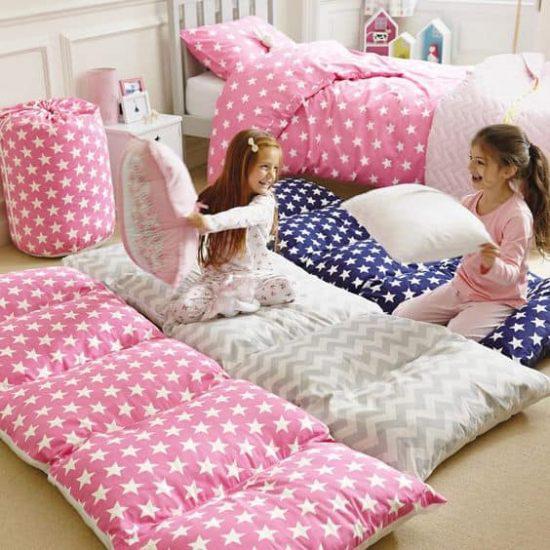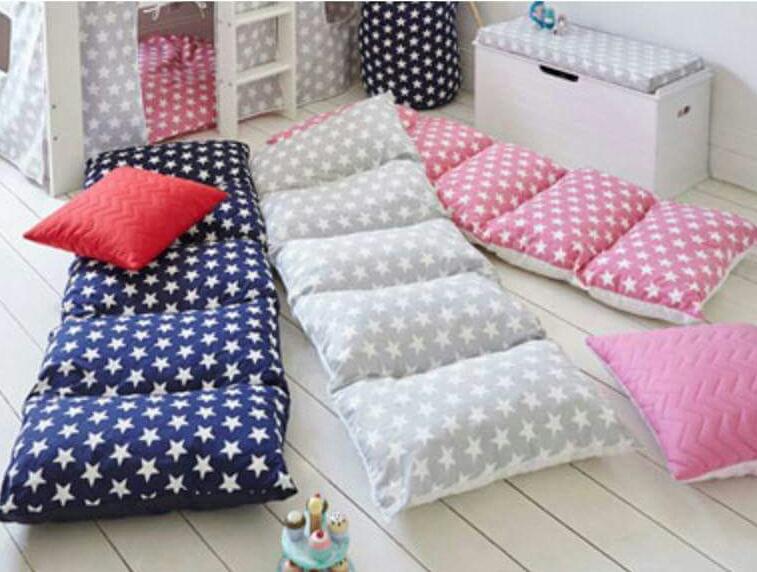The first image is the image on the left, the second image is the image on the right. Considering the images on both sides, is "In the left image two kids are holding pillows" valid? Answer yes or no. Yes. 